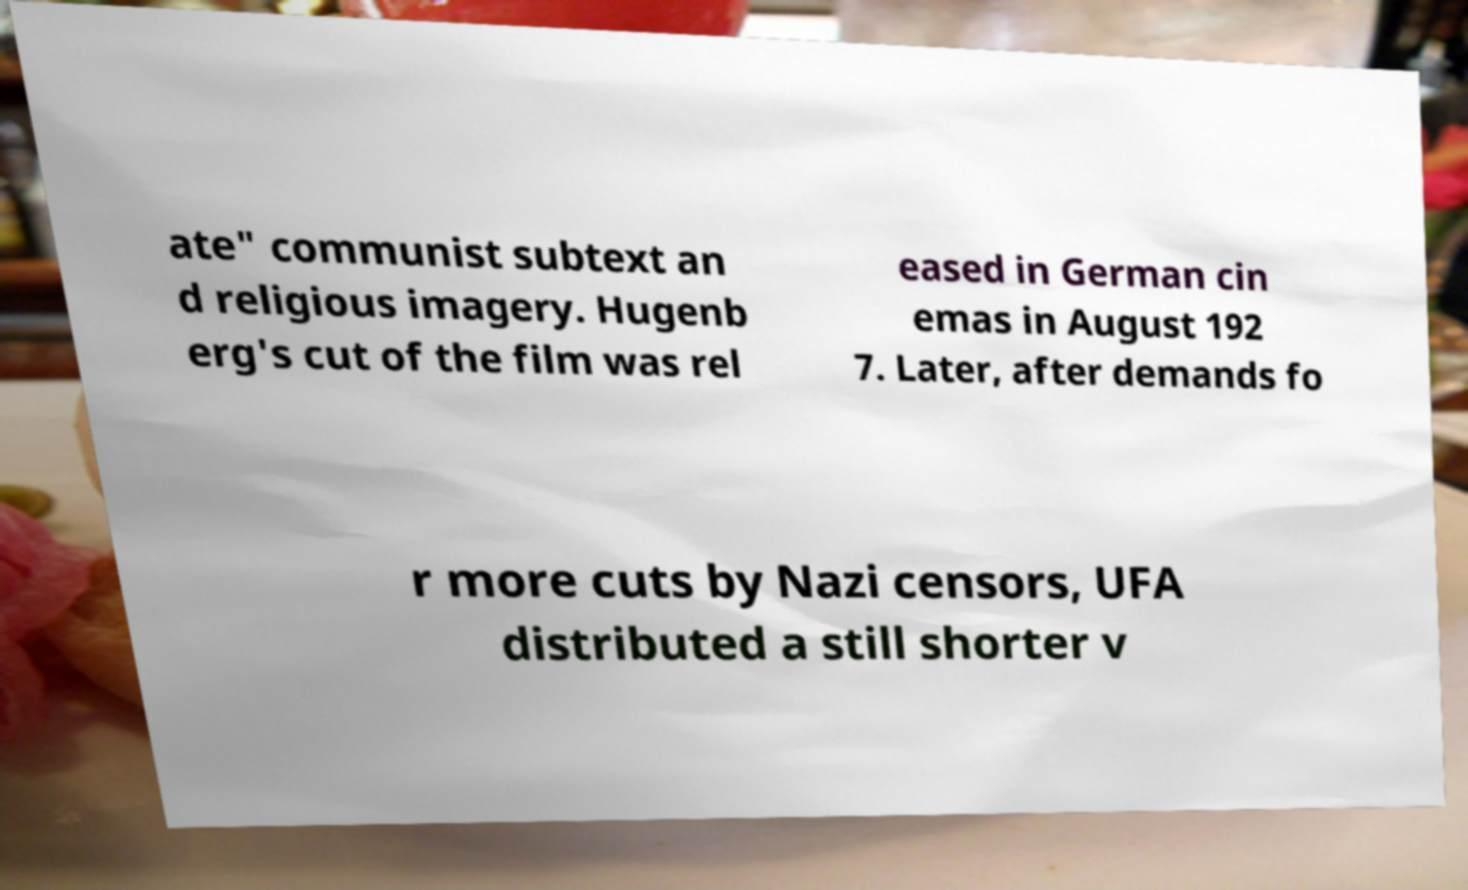I need the written content from this picture converted into text. Can you do that? ate" communist subtext an d religious imagery. Hugenb erg's cut of the film was rel eased in German cin emas in August 192 7. Later, after demands fo r more cuts by Nazi censors, UFA distributed a still shorter v 